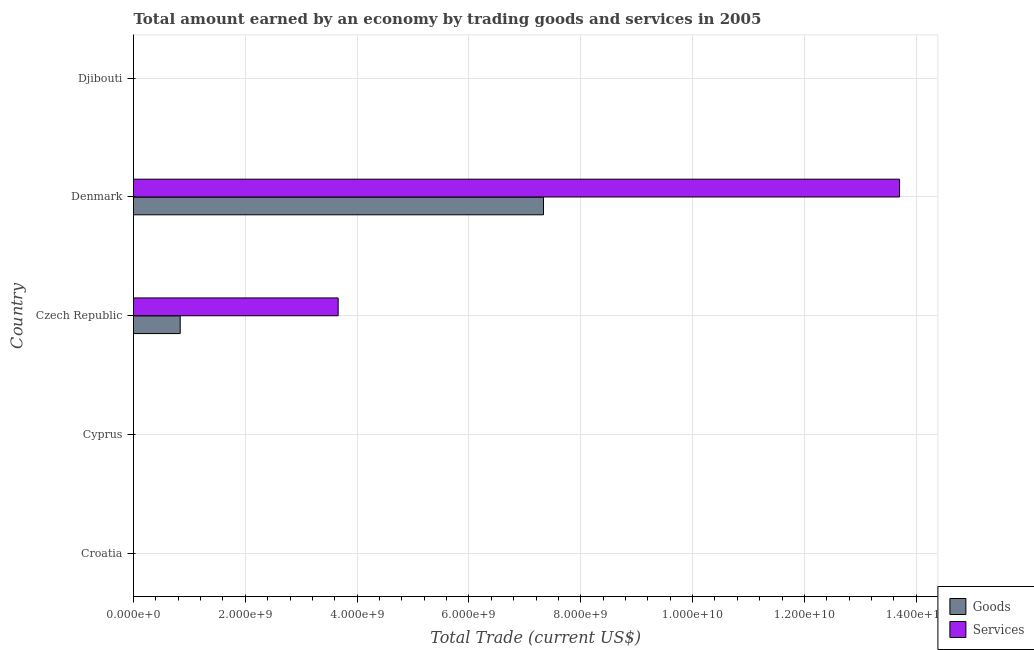How many different coloured bars are there?
Keep it short and to the point. 2. Are the number of bars on each tick of the Y-axis equal?
Offer a terse response. No. What is the label of the 5th group of bars from the top?
Ensure brevity in your answer.  Croatia. In how many cases, is the number of bars for a given country not equal to the number of legend labels?
Offer a terse response. 3. What is the amount earned by trading goods in Denmark?
Your answer should be compact. 7.33e+09. Across all countries, what is the maximum amount earned by trading services?
Keep it short and to the point. 1.37e+1. In which country was the amount earned by trading goods maximum?
Provide a short and direct response. Denmark. What is the total amount earned by trading goods in the graph?
Your response must be concise. 8.17e+09. What is the difference between the amount earned by trading services in Czech Republic and that in Denmark?
Keep it short and to the point. -1.00e+1. What is the difference between the amount earned by trading goods in Czech Republic and the amount earned by trading services in Cyprus?
Keep it short and to the point. 8.35e+08. What is the average amount earned by trading goods per country?
Offer a terse response. 1.63e+09. What is the difference between the amount earned by trading services and amount earned by trading goods in Denmark?
Your answer should be compact. 6.37e+09. In how many countries, is the amount earned by trading services greater than 4000000000 US$?
Your answer should be very brief. 1. What is the ratio of the amount earned by trading goods in Czech Republic to that in Denmark?
Give a very brief answer. 0.11. What is the difference between the highest and the lowest amount earned by trading services?
Your answer should be very brief. 1.37e+1. In how many countries, is the amount earned by trading services greater than the average amount earned by trading services taken over all countries?
Give a very brief answer. 2. How many bars are there?
Give a very brief answer. 4. Are all the bars in the graph horizontal?
Keep it short and to the point. Yes. Where does the legend appear in the graph?
Your answer should be compact. Bottom right. How many legend labels are there?
Your answer should be very brief. 2. What is the title of the graph?
Ensure brevity in your answer.  Total amount earned by an economy by trading goods and services in 2005. Does "Travel services" appear as one of the legend labels in the graph?
Your answer should be very brief. No. What is the label or title of the X-axis?
Your answer should be compact. Total Trade (current US$). What is the Total Trade (current US$) in Goods in Croatia?
Make the answer very short. 0. What is the Total Trade (current US$) in Services in Croatia?
Make the answer very short. 0. What is the Total Trade (current US$) of Goods in Cyprus?
Make the answer very short. 0. What is the Total Trade (current US$) in Services in Cyprus?
Give a very brief answer. 0. What is the Total Trade (current US$) in Goods in Czech Republic?
Make the answer very short. 8.35e+08. What is the Total Trade (current US$) in Services in Czech Republic?
Make the answer very short. 3.66e+09. What is the Total Trade (current US$) in Goods in Denmark?
Provide a short and direct response. 7.33e+09. What is the Total Trade (current US$) in Services in Denmark?
Offer a very short reply. 1.37e+1. What is the Total Trade (current US$) in Goods in Djibouti?
Provide a succinct answer. 0. What is the Total Trade (current US$) in Services in Djibouti?
Give a very brief answer. 0. Across all countries, what is the maximum Total Trade (current US$) of Goods?
Your answer should be compact. 7.33e+09. Across all countries, what is the maximum Total Trade (current US$) of Services?
Ensure brevity in your answer.  1.37e+1. Across all countries, what is the minimum Total Trade (current US$) in Goods?
Your answer should be compact. 0. What is the total Total Trade (current US$) of Goods in the graph?
Offer a very short reply. 8.17e+09. What is the total Total Trade (current US$) in Services in the graph?
Offer a very short reply. 1.74e+1. What is the difference between the Total Trade (current US$) of Goods in Czech Republic and that in Denmark?
Keep it short and to the point. -6.50e+09. What is the difference between the Total Trade (current US$) in Services in Czech Republic and that in Denmark?
Provide a short and direct response. -1.00e+1. What is the difference between the Total Trade (current US$) of Goods in Czech Republic and the Total Trade (current US$) of Services in Denmark?
Offer a terse response. -1.29e+1. What is the average Total Trade (current US$) in Goods per country?
Ensure brevity in your answer.  1.63e+09. What is the average Total Trade (current US$) in Services per country?
Keep it short and to the point. 3.47e+09. What is the difference between the Total Trade (current US$) in Goods and Total Trade (current US$) in Services in Czech Republic?
Your response must be concise. -2.83e+09. What is the difference between the Total Trade (current US$) of Goods and Total Trade (current US$) of Services in Denmark?
Provide a short and direct response. -6.37e+09. What is the ratio of the Total Trade (current US$) of Goods in Czech Republic to that in Denmark?
Keep it short and to the point. 0.11. What is the ratio of the Total Trade (current US$) of Services in Czech Republic to that in Denmark?
Make the answer very short. 0.27. What is the difference between the highest and the lowest Total Trade (current US$) in Goods?
Your answer should be very brief. 7.33e+09. What is the difference between the highest and the lowest Total Trade (current US$) in Services?
Your answer should be compact. 1.37e+1. 